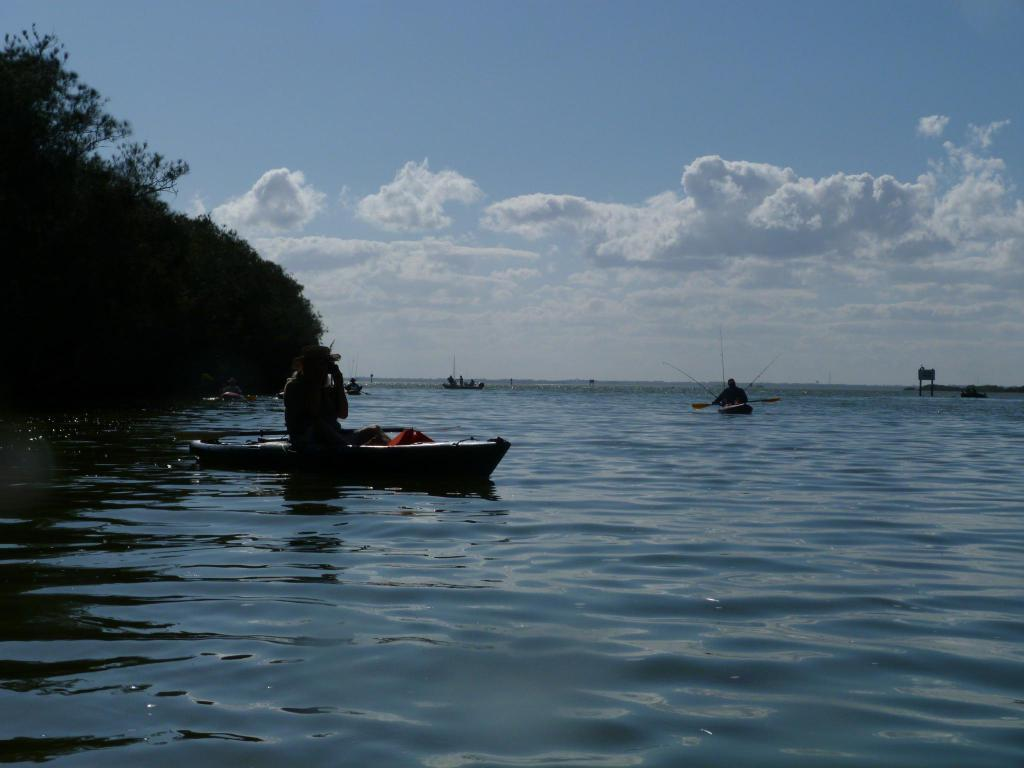What are the people in the image doing? A: The people in the image are sitting on boats. Where are the boats located? The boats are on the water. What can be seen on the left side of the image? There are trees on the left side of the image. What is visible in the background of the image? The sky is visible in the image. What is the tendency of the station to touch the trees in the image? There is no station present in the image, and therefore no such interaction can be observed. 